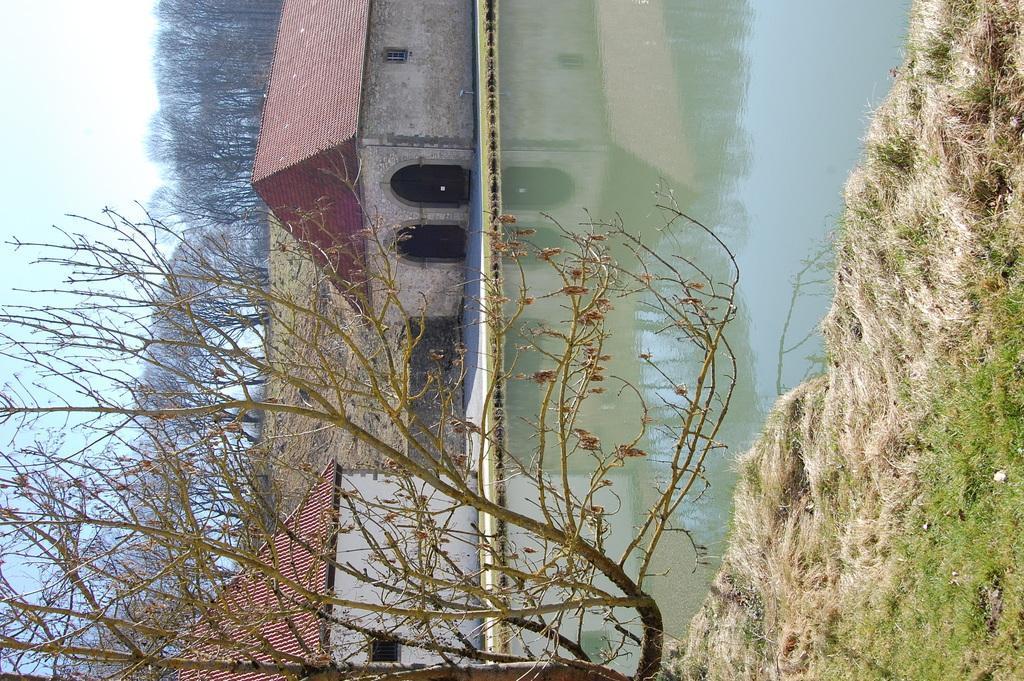In one or two sentences, can you explain what this image depicts? In this picture we can see grass, water, houses and trees. In the background of the image we can see the sky. 